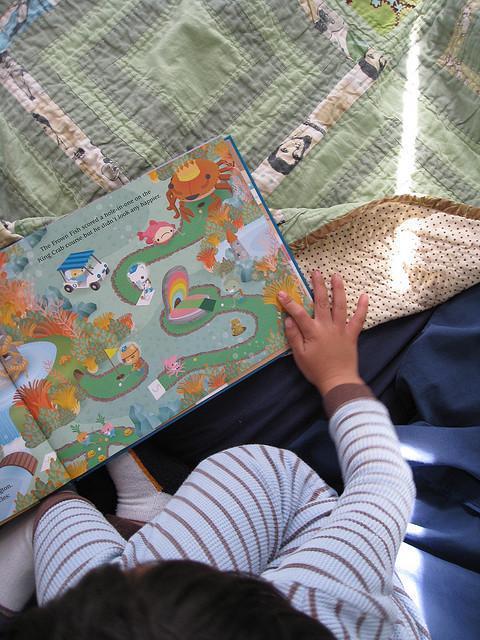How many people can you see?
Give a very brief answer. 1. How many beds are in the photo?
Give a very brief answer. 2. How many kites are flying?
Give a very brief answer. 0. 